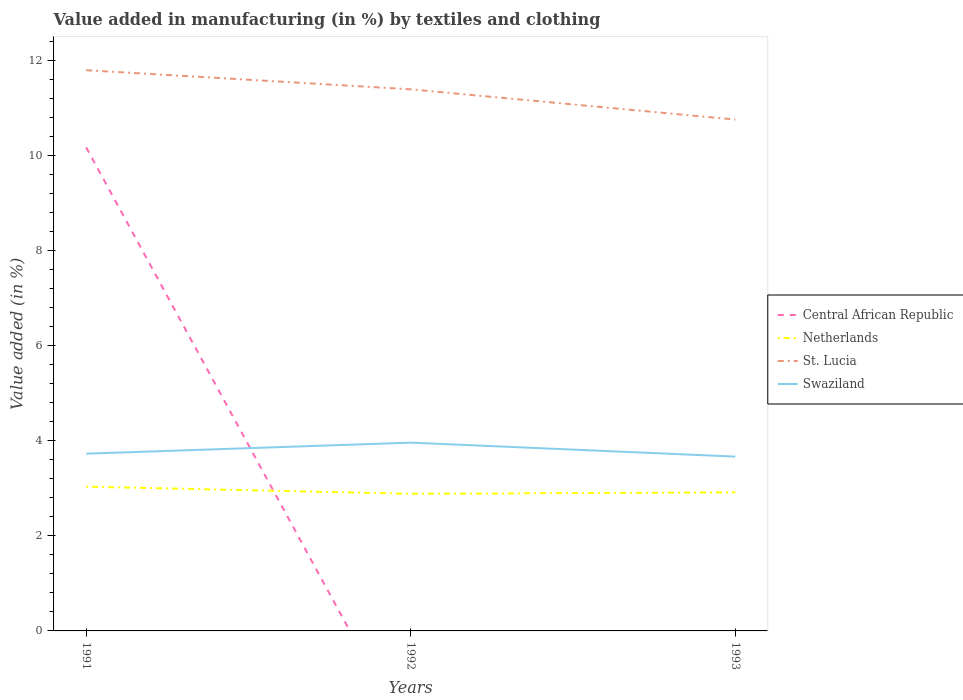How many different coloured lines are there?
Give a very brief answer. 4. Is the number of lines equal to the number of legend labels?
Keep it short and to the point. No. What is the total percentage of value added in manufacturing by textiles and clothing in St. Lucia in the graph?
Keep it short and to the point. 0.64. What is the difference between the highest and the second highest percentage of value added in manufacturing by textiles and clothing in Swaziland?
Offer a terse response. 0.29. Is the percentage of value added in manufacturing by textiles and clothing in Netherlands strictly greater than the percentage of value added in manufacturing by textiles and clothing in St. Lucia over the years?
Keep it short and to the point. Yes. How many lines are there?
Offer a terse response. 4. What is the difference between two consecutive major ticks on the Y-axis?
Offer a very short reply. 2. Are the values on the major ticks of Y-axis written in scientific E-notation?
Your answer should be very brief. No. Does the graph contain grids?
Your answer should be very brief. No. How many legend labels are there?
Ensure brevity in your answer.  4. How are the legend labels stacked?
Keep it short and to the point. Vertical. What is the title of the graph?
Provide a short and direct response. Value added in manufacturing (in %) by textiles and clothing. What is the label or title of the X-axis?
Give a very brief answer. Years. What is the label or title of the Y-axis?
Your answer should be very brief. Value added (in %). What is the Value added (in %) of Central African Republic in 1991?
Offer a very short reply. 10.16. What is the Value added (in %) in Netherlands in 1991?
Ensure brevity in your answer.  3.03. What is the Value added (in %) of St. Lucia in 1991?
Your answer should be compact. 11.79. What is the Value added (in %) of Swaziland in 1991?
Offer a very short reply. 3.73. What is the Value added (in %) of Netherlands in 1992?
Your answer should be very brief. 2.88. What is the Value added (in %) in St. Lucia in 1992?
Your response must be concise. 11.38. What is the Value added (in %) of Swaziland in 1992?
Provide a succinct answer. 3.96. What is the Value added (in %) in Central African Republic in 1993?
Make the answer very short. 0. What is the Value added (in %) of Netherlands in 1993?
Your answer should be compact. 2.91. What is the Value added (in %) in St. Lucia in 1993?
Make the answer very short. 10.75. What is the Value added (in %) of Swaziland in 1993?
Keep it short and to the point. 3.66. Across all years, what is the maximum Value added (in %) of Central African Republic?
Give a very brief answer. 10.16. Across all years, what is the maximum Value added (in %) in Netherlands?
Provide a succinct answer. 3.03. Across all years, what is the maximum Value added (in %) of St. Lucia?
Give a very brief answer. 11.79. Across all years, what is the maximum Value added (in %) of Swaziland?
Ensure brevity in your answer.  3.96. Across all years, what is the minimum Value added (in %) of Netherlands?
Provide a short and direct response. 2.88. Across all years, what is the minimum Value added (in %) of St. Lucia?
Your response must be concise. 10.75. Across all years, what is the minimum Value added (in %) of Swaziland?
Your response must be concise. 3.66. What is the total Value added (in %) of Central African Republic in the graph?
Your answer should be very brief. 10.16. What is the total Value added (in %) of Netherlands in the graph?
Make the answer very short. 8.83. What is the total Value added (in %) of St. Lucia in the graph?
Offer a very short reply. 33.92. What is the total Value added (in %) in Swaziland in the graph?
Give a very brief answer. 11.35. What is the difference between the Value added (in %) in Netherlands in 1991 and that in 1992?
Make the answer very short. 0.15. What is the difference between the Value added (in %) in St. Lucia in 1991 and that in 1992?
Keep it short and to the point. 0.4. What is the difference between the Value added (in %) in Swaziland in 1991 and that in 1992?
Keep it short and to the point. -0.23. What is the difference between the Value added (in %) of Netherlands in 1991 and that in 1993?
Your answer should be compact. 0.12. What is the difference between the Value added (in %) of St. Lucia in 1991 and that in 1993?
Offer a terse response. 1.04. What is the difference between the Value added (in %) in Swaziland in 1991 and that in 1993?
Give a very brief answer. 0.06. What is the difference between the Value added (in %) in Netherlands in 1992 and that in 1993?
Offer a very short reply. -0.03. What is the difference between the Value added (in %) in St. Lucia in 1992 and that in 1993?
Offer a terse response. 0.64. What is the difference between the Value added (in %) in Swaziland in 1992 and that in 1993?
Make the answer very short. 0.29. What is the difference between the Value added (in %) in Central African Republic in 1991 and the Value added (in %) in Netherlands in 1992?
Your response must be concise. 7.28. What is the difference between the Value added (in %) in Central African Republic in 1991 and the Value added (in %) in St. Lucia in 1992?
Keep it short and to the point. -1.22. What is the difference between the Value added (in %) in Central African Republic in 1991 and the Value added (in %) in Swaziland in 1992?
Offer a terse response. 6.21. What is the difference between the Value added (in %) in Netherlands in 1991 and the Value added (in %) in St. Lucia in 1992?
Your response must be concise. -8.35. What is the difference between the Value added (in %) in Netherlands in 1991 and the Value added (in %) in Swaziland in 1992?
Give a very brief answer. -0.92. What is the difference between the Value added (in %) of St. Lucia in 1991 and the Value added (in %) of Swaziland in 1992?
Provide a succinct answer. 7.83. What is the difference between the Value added (in %) in Central African Republic in 1991 and the Value added (in %) in Netherlands in 1993?
Your answer should be very brief. 7.25. What is the difference between the Value added (in %) in Central African Republic in 1991 and the Value added (in %) in St. Lucia in 1993?
Offer a very short reply. -0.58. What is the difference between the Value added (in %) of Central African Republic in 1991 and the Value added (in %) of Swaziland in 1993?
Your answer should be very brief. 6.5. What is the difference between the Value added (in %) in Netherlands in 1991 and the Value added (in %) in St. Lucia in 1993?
Make the answer very short. -7.72. What is the difference between the Value added (in %) of Netherlands in 1991 and the Value added (in %) of Swaziland in 1993?
Offer a very short reply. -0.63. What is the difference between the Value added (in %) in St. Lucia in 1991 and the Value added (in %) in Swaziland in 1993?
Your answer should be very brief. 8.12. What is the difference between the Value added (in %) in Netherlands in 1992 and the Value added (in %) in St. Lucia in 1993?
Provide a short and direct response. -7.87. What is the difference between the Value added (in %) in Netherlands in 1992 and the Value added (in %) in Swaziland in 1993?
Your response must be concise. -0.78. What is the difference between the Value added (in %) of St. Lucia in 1992 and the Value added (in %) of Swaziland in 1993?
Offer a very short reply. 7.72. What is the average Value added (in %) in Central African Republic per year?
Ensure brevity in your answer.  3.39. What is the average Value added (in %) of Netherlands per year?
Provide a short and direct response. 2.94. What is the average Value added (in %) in St. Lucia per year?
Keep it short and to the point. 11.31. What is the average Value added (in %) in Swaziland per year?
Give a very brief answer. 3.78. In the year 1991, what is the difference between the Value added (in %) in Central African Republic and Value added (in %) in Netherlands?
Ensure brevity in your answer.  7.13. In the year 1991, what is the difference between the Value added (in %) in Central African Republic and Value added (in %) in St. Lucia?
Give a very brief answer. -1.62. In the year 1991, what is the difference between the Value added (in %) in Central African Republic and Value added (in %) in Swaziland?
Offer a very short reply. 6.44. In the year 1991, what is the difference between the Value added (in %) in Netherlands and Value added (in %) in St. Lucia?
Give a very brief answer. -8.75. In the year 1991, what is the difference between the Value added (in %) of Netherlands and Value added (in %) of Swaziland?
Keep it short and to the point. -0.69. In the year 1991, what is the difference between the Value added (in %) in St. Lucia and Value added (in %) in Swaziland?
Offer a terse response. 8.06. In the year 1992, what is the difference between the Value added (in %) of Netherlands and Value added (in %) of St. Lucia?
Provide a succinct answer. -8.5. In the year 1992, what is the difference between the Value added (in %) of Netherlands and Value added (in %) of Swaziland?
Provide a short and direct response. -1.08. In the year 1992, what is the difference between the Value added (in %) in St. Lucia and Value added (in %) in Swaziland?
Keep it short and to the point. 7.43. In the year 1993, what is the difference between the Value added (in %) in Netherlands and Value added (in %) in St. Lucia?
Offer a terse response. -7.84. In the year 1993, what is the difference between the Value added (in %) in Netherlands and Value added (in %) in Swaziland?
Make the answer very short. -0.75. In the year 1993, what is the difference between the Value added (in %) of St. Lucia and Value added (in %) of Swaziland?
Your answer should be very brief. 7.08. What is the ratio of the Value added (in %) of Netherlands in 1991 to that in 1992?
Keep it short and to the point. 1.05. What is the ratio of the Value added (in %) of St. Lucia in 1991 to that in 1992?
Offer a terse response. 1.04. What is the ratio of the Value added (in %) of Swaziland in 1991 to that in 1992?
Provide a succinct answer. 0.94. What is the ratio of the Value added (in %) of Netherlands in 1991 to that in 1993?
Provide a short and direct response. 1.04. What is the ratio of the Value added (in %) in St. Lucia in 1991 to that in 1993?
Ensure brevity in your answer.  1.1. What is the ratio of the Value added (in %) in Swaziland in 1991 to that in 1993?
Your answer should be very brief. 1.02. What is the ratio of the Value added (in %) of Netherlands in 1992 to that in 1993?
Offer a very short reply. 0.99. What is the ratio of the Value added (in %) in St. Lucia in 1992 to that in 1993?
Ensure brevity in your answer.  1.06. What is the difference between the highest and the second highest Value added (in %) of Netherlands?
Ensure brevity in your answer.  0.12. What is the difference between the highest and the second highest Value added (in %) in St. Lucia?
Ensure brevity in your answer.  0.4. What is the difference between the highest and the second highest Value added (in %) of Swaziland?
Provide a succinct answer. 0.23. What is the difference between the highest and the lowest Value added (in %) in Central African Republic?
Offer a terse response. 10.16. What is the difference between the highest and the lowest Value added (in %) in Netherlands?
Provide a succinct answer. 0.15. What is the difference between the highest and the lowest Value added (in %) of St. Lucia?
Give a very brief answer. 1.04. What is the difference between the highest and the lowest Value added (in %) in Swaziland?
Your answer should be compact. 0.29. 